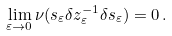<formula> <loc_0><loc_0><loc_500><loc_500>\lim _ { \varepsilon \to 0 } \nu ( s _ { \varepsilon } \delta z _ { \varepsilon } ^ { - 1 } \delta s _ { \varepsilon } ) = 0 \, .</formula> 